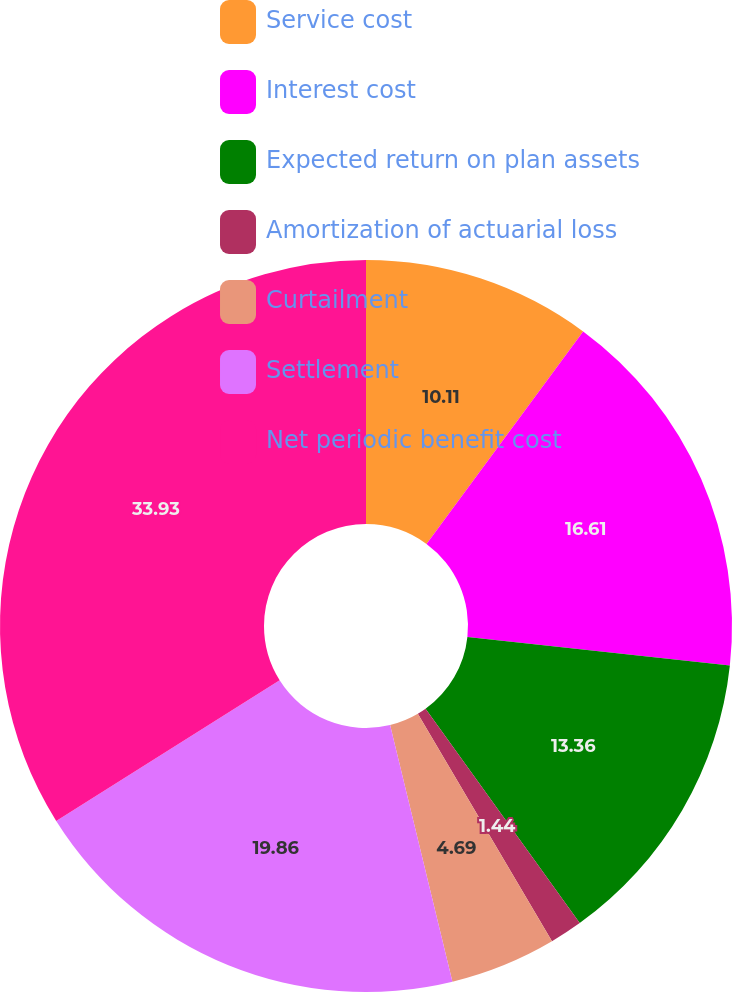Convert chart. <chart><loc_0><loc_0><loc_500><loc_500><pie_chart><fcel>Service cost<fcel>Interest cost<fcel>Expected return on plan assets<fcel>Amortization of actuarial loss<fcel>Curtailment<fcel>Settlement<fcel>Net periodic benefit cost<nl><fcel>10.11%<fcel>16.61%<fcel>13.36%<fcel>1.44%<fcel>4.69%<fcel>19.86%<fcel>33.94%<nl></chart> 